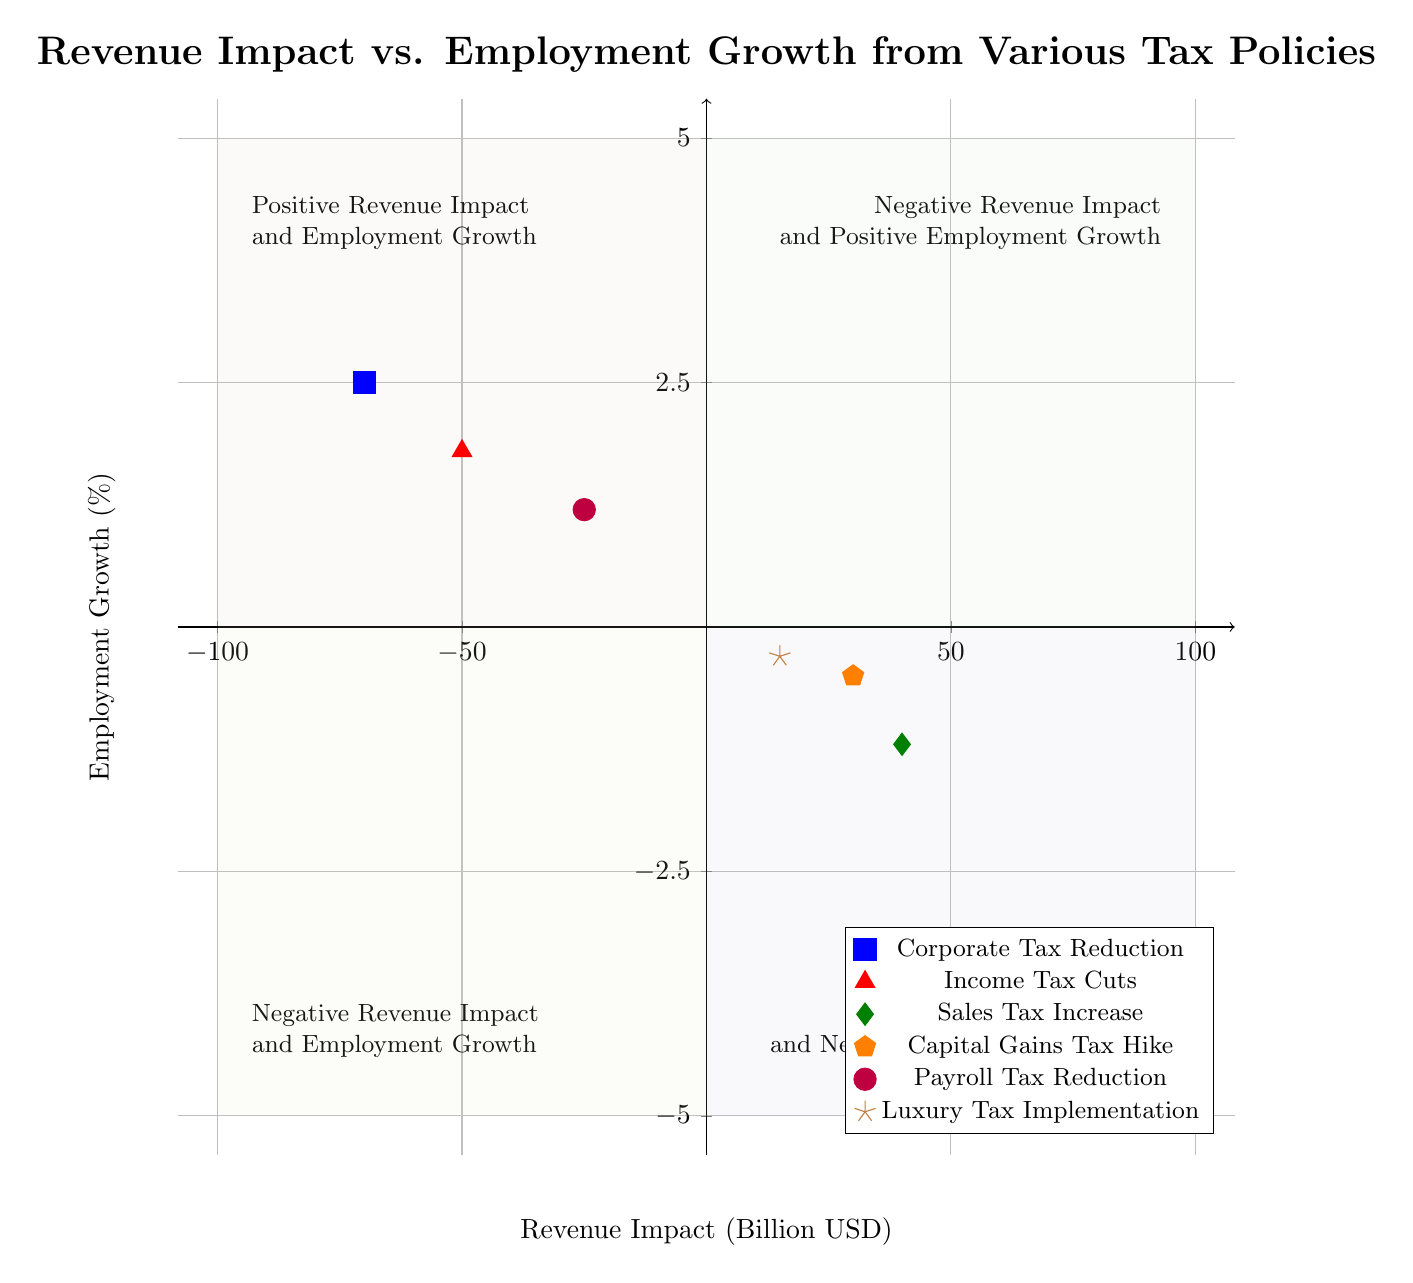What is the revenue impact of the Corporate Tax Reduction policy? The Corporate Tax Reduction policy is located at the point (-70, 2.5) on the diagram. The x-coordinate represents the revenue impact, which is -70 billion USD.
Answer: -70 billion USD Which policy shows a positive employment growth? By analyzing the y-coordinates of each policy, Corporate Tax Reduction (2.5%), Income Tax Cuts (1.8%), Payroll Tax Reduction (1.2%) show positive employment growth, but the question seeks only one answer.
Answer: Corporate Tax Reduction How many policies resulted in negative revenue impact? The policies with negative revenue impact are Corporate Tax Reduction, Income Tax Cuts, and Payroll Tax Reduction, totaling three policies.
Answer: 3 What is the employment growth percentage for the Sales Tax Increase policy? The Sales Tax Increase is represented at the point (40, -1.2) on the diagram, where the y-coordinate indicates employment growth, which is -1.2%.
Answer: -1.2% Which quadrant contains policies with both positive revenue impact and negative employment growth? The Sales Tax Increase (40, -1.2) and Capital Gains Tax Hike (30, -0.5) lie in the quadrant labeled as Positive Revenue Impact and Negative Employment Growth since both have positive x-coordinates and negative y-coordinates.
Answer: Bottom right Compare the revenue impact of Income Tax Cuts and Payroll Tax Reduction. Which one has a smaller impact? Income Tax Cuts is at (-50) and Payroll Tax Reduction is at (-25). Since -50 is further left than -25 on the x-axis, it indicates a smaller revenue impact (more negative).
Answer: Income Tax Cuts What is the highest employment growth percentage among the policies? The policies display employment growth percentages of 2.5%, 1.8%, 1.2%, -1.2%, -0.5%, and -0.3%. Out of these, 2.5% from Corporate Tax Reduction is the highest.
Answer: 2.5% Which policy is positioned closest to the origin of the quadrant chart? To determine proximity to the origin (0,0), we compare the distance of each policy point from the origin. The policy with the closest coordinates is Payroll Tax Reduction at (-25, 1.2).
Answer: Payroll Tax Reduction 